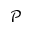Convert formula to latex. <formula><loc_0><loc_0><loc_500><loc_500>\mathcal { P }</formula> 